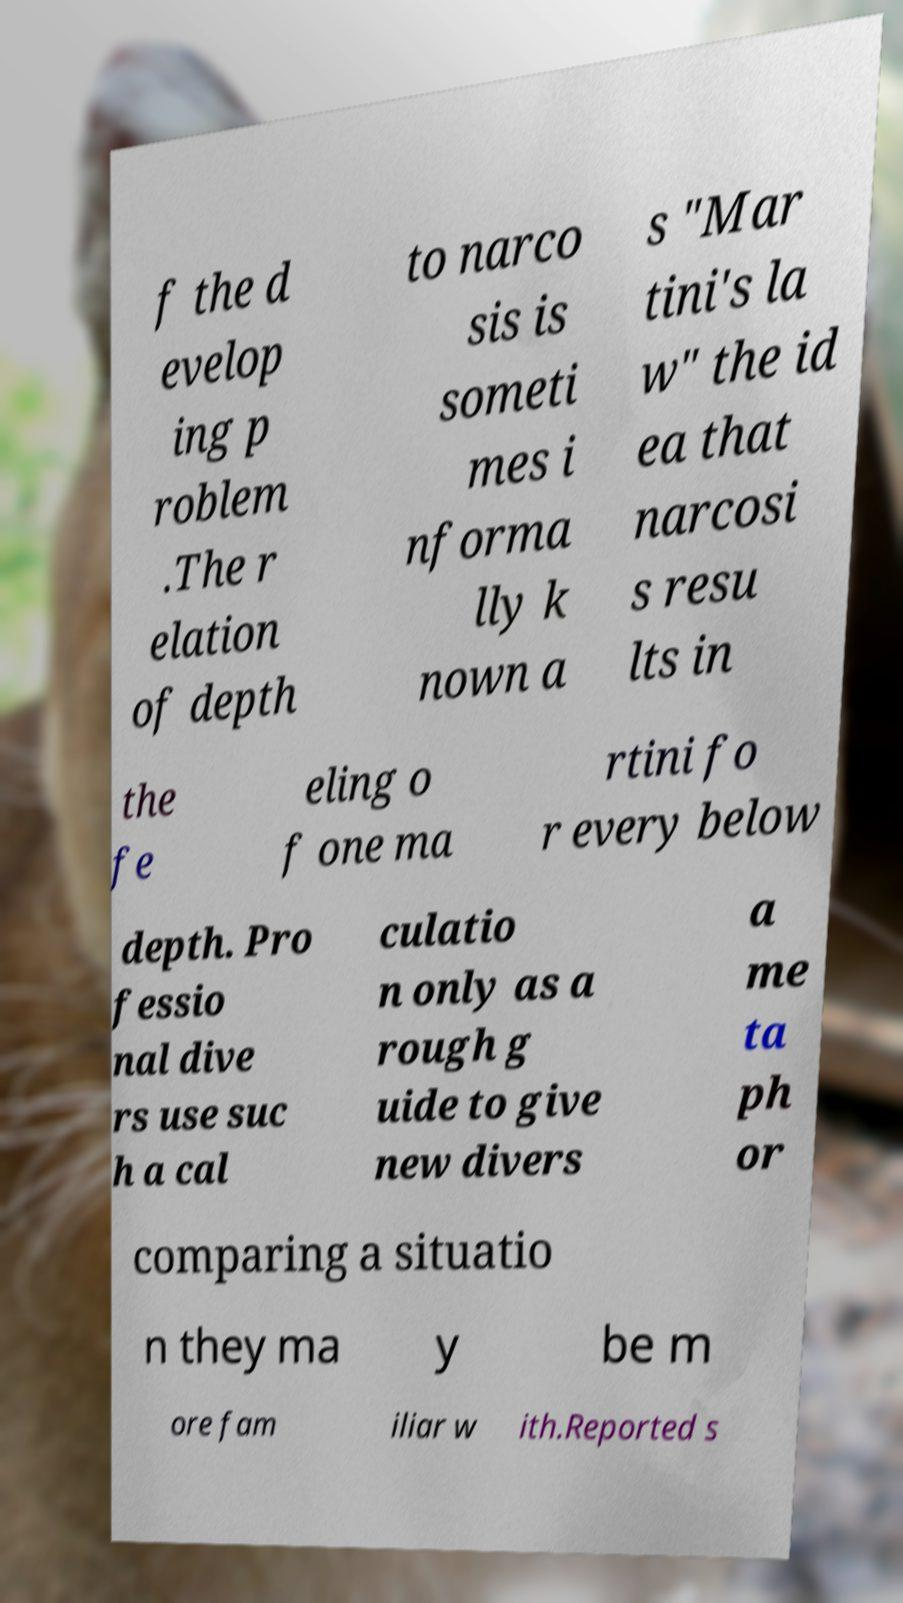For documentation purposes, I need the text within this image transcribed. Could you provide that? f the d evelop ing p roblem .The r elation of depth to narco sis is someti mes i nforma lly k nown a s "Mar tini's la w" the id ea that narcosi s resu lts in the fe eling o f one ma rtini fo r every below depth. Pro fessio nal dive rs use suc h a cal culatio n only as a rough g uide to give new divers a me ta ph or comparing a situatio n they ma y be m ore fam iliar w ith.Reported s 